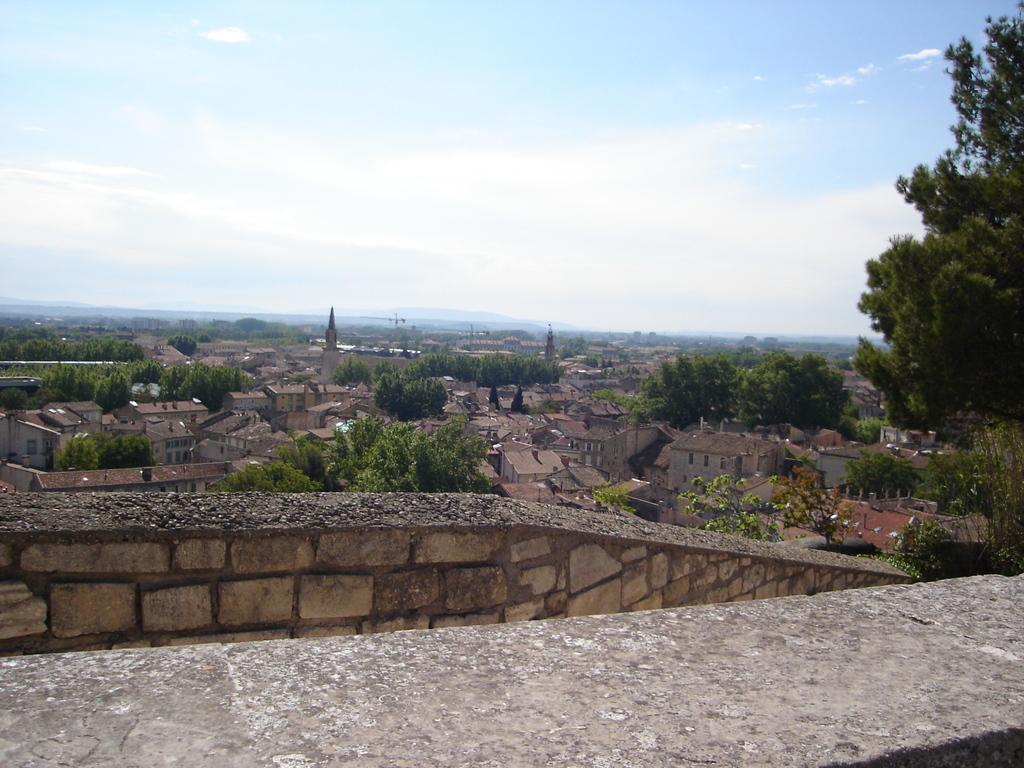What is the main subject in the center of the image? There is a wall and slab in the center of the image. What can be seen in the background of the image? The sky, clouds, buildings, windows, trees, and a few other objects are visible in the background of the image. How many wounds can be seen on the wall in the image? There is no mention of any wounds on the wall in the image. 